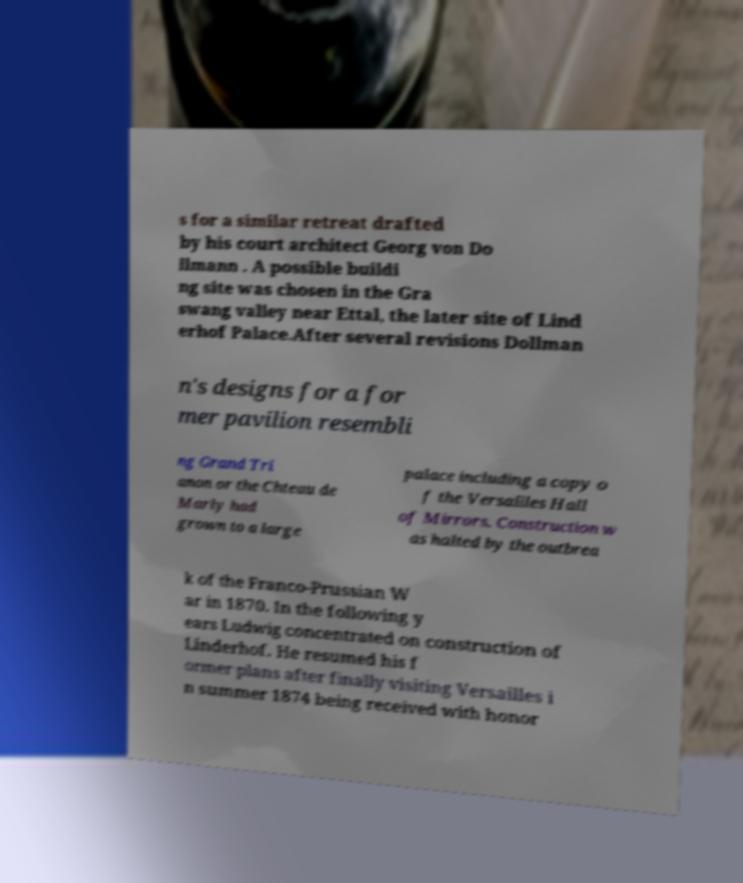Please read and relay the text visible in this image. What does it say? s for a similar retreat drafted by his court architect Georg von Do llmann . A possible buildi ng site was chosen in the Gra swang valley near Ettal, the later site of Lind erhof Palace.After several revisions Dollman n's designs for a for mer pavilion resembli ng Grand Tri anon or the Chteau de Marly had grown to a large palace including a copy o f the Versailles Hall of Mirrors. Construction w as halted by the outbrea k of the Franco-Prussian W ar in 1870. In the following y ears Ludwig concentrated on construction of Linderhof. He resumed his f ormer plans after finally visiting Versailles i n summer 1874 being received with honor 